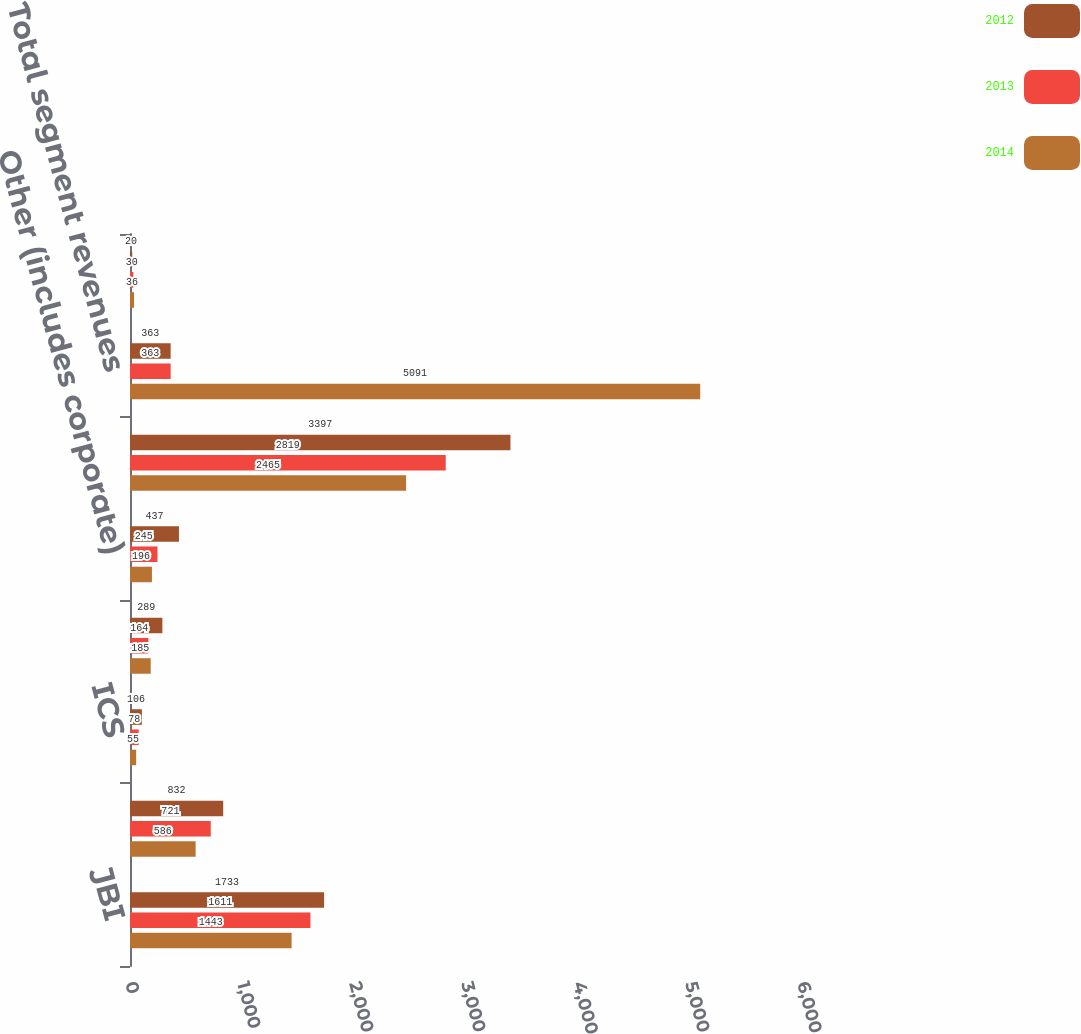Convert chart to OTSL. <chart><loc_0><loc_0><loc_500><loc_500><stacked_bar_chart><ecel><fcel>JBI<fcel>DCS<fcel>ICS<fcel>JBT<fcel>Other (includes corporate)<fcel>Total<fcel>Total segment revenues<fcel>Intersegment eliminations<nl><fcel>2012<fcel>1733<fcel>832<fcel>106<fcel>289<fcel>437<fcel>3397<fcel>363<fcel>20<nl><fcel>2013<fcel>1611<fcel>721<fcel>78<fcel>164<fcel>245<fcel>2819<fcel>363<fcel>30<nl><fcel>2014<fcel>1443<fcel>586<fcel>55<fcel>185<fcel>196<fcel>2465<fcel>5091<fcel>36<nl></chart> 